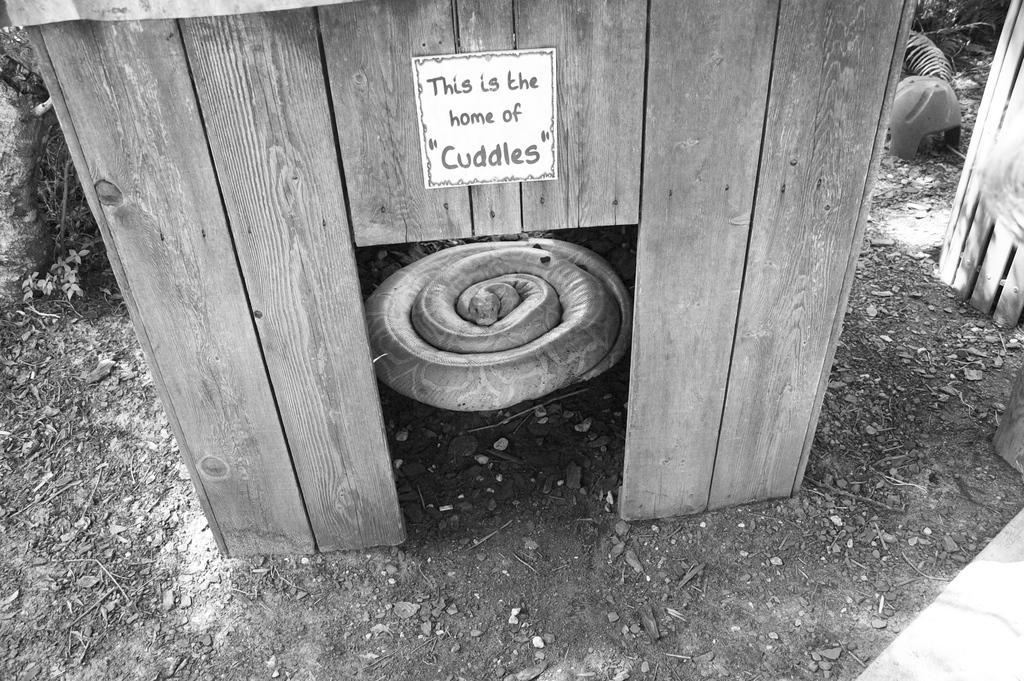How would you summarize this image in a sentence or two? In the picture we can see a small wooden house inside it, we can see a snake, which is rolled and around the wooden house we can see a muddy surface. 